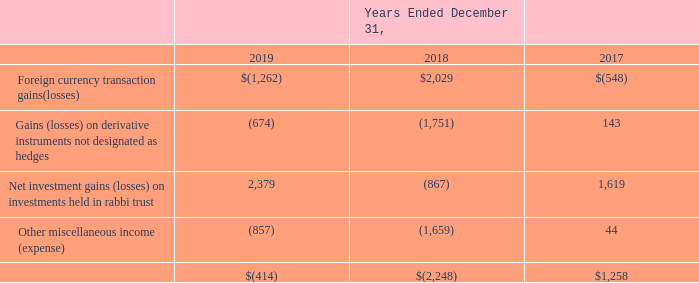Note 26. Other Income (Expense)
Other income (expense), net consisted of the following (in thousands):
What was the Other miscellaneous income (expense) in 2019?
Answer scale should be: thousand. (857). What was the Net investment gains (losses) on investments held in rabbi trust in 2017?
Answer scale should be: thousand. 1,619. Which years was Other income (expense), net calculated? 2019, 2018, 2017. In how many years was Other income, net a negative value? 2019##2018
Answer: 2. What was the overall change in Net investment gains  on investments held in rabbi trust in 2019 from 2017?
Answer scale should be: thousand. 2,379-1,619
Answer: 760. What was the overall percentage change in Net investment gains  on investments held in rabbi trust in 2019 from 2017?
Answer scale should be: percent. (2,379-1,619)/1,619
Answer: 46.94. 